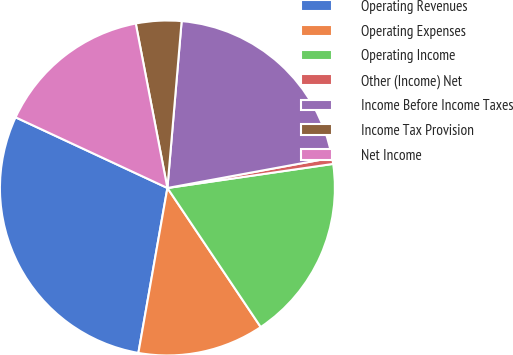Convert chart. <chart><loc_0><loc_0><loc_500><loc_500><pie_chart><fcel>Operating Revenues<fcel>Operating Expenses<fcel>Operating Income<fcel>Other (Income) Net<fcel>Income Before Income Taxes<fcel>Income Tax Provision<fcel>Net Income<nl><fcel>29.16%<fcel>12.18%<fcel>17.89%<fcel>0.6%<fcel>20.75%<fcel>4.38%<fcel>15.04%<nl></chart> 